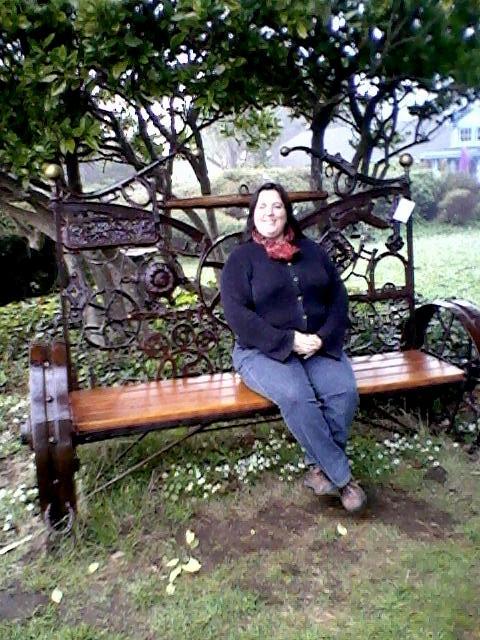Is the woman posing for a photograph?
Write a very short answer. Yes. What is the back of the bench made of?
Answer briefly. Iron. What color is the bench?
Quick response, please. Brown. 